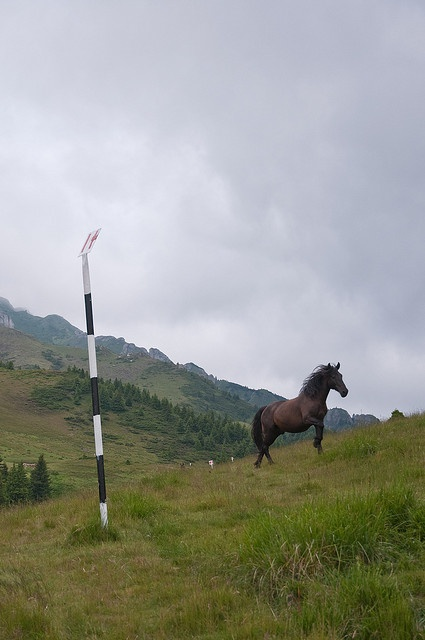Describe the objects in this image and their specific colors. I can see a horse in lavender, black, gray, and maroon tones in this image. 